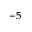Convert formula to latex. <formula><loc_0><loc_0><loc_500><loc_500>^ { - 5 }</formula> 